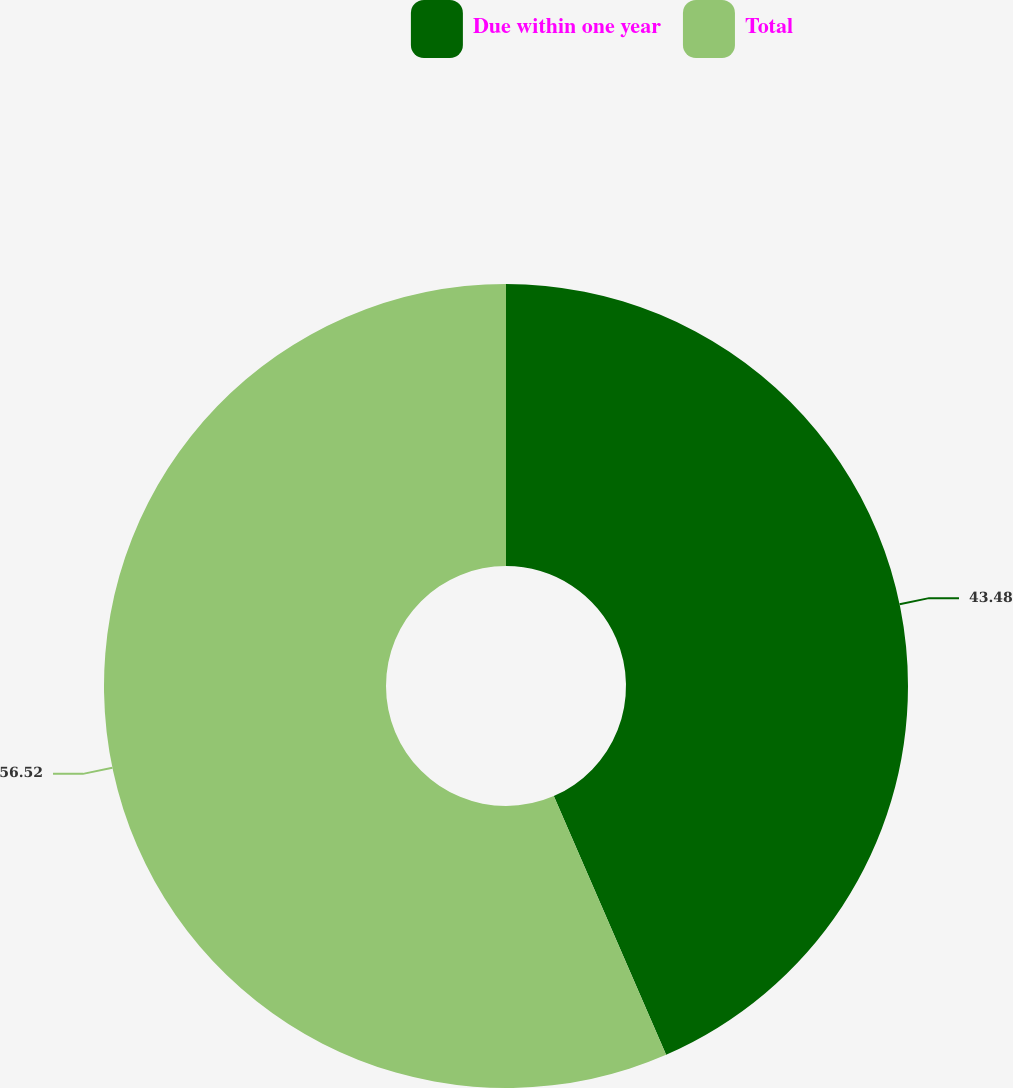<chart> <loc_0><loc_0><loc_500><loc_500><pie_chart><fcel>Due within one year<fcel>Total<nl><fcel>43.48%<fcel>56.52%<nl></chart> 